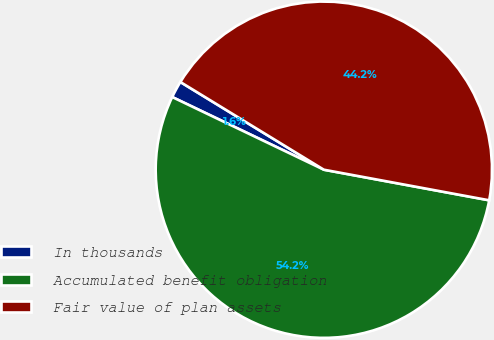Convert chart. <chart><loc_0><loc_0><loc_500><loc_500><pie_chart><fcel>In thousands<fcel>Accumulated benefit obligation<fcel>Fair value of plan assets<nl><fcel>1.62%<fcel>54.2%<fcel>44.18%<nl></chart> 